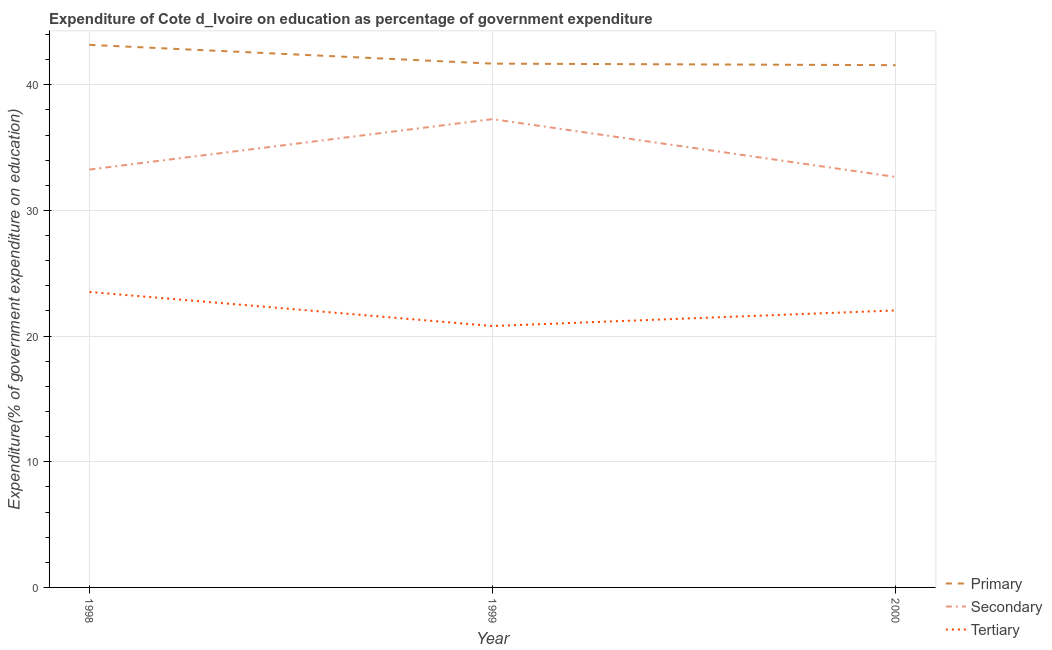How many different coloured lines are there?
Offer a very short reply. 3. What is the expenditure on secondary education in 1999?
Keep it short and to the point. 37.26. Across all years, what is the maximum expenditure on secondary education?
Provide a succinct answer. 37.26. Across all years, what is the minimum expenditure on primary education?
Make the answer very short. 41.56. In which year was the expenditure on tertiary education maximum?
Offer a terse response. 1998. In which year was the expenditure on tertiary education minimum?
Give a very brief answer. 1999. What is the total expenditure on tertiary education in the graph?
Ensure brevity in your answer.  66.36. What is the difference between the expenditure on primary education in 1998 and that in 2000?
Make the answer very short. 1.61. What is the difference between the expenditure on tertiary education in 1999 and the expenditure on secondary education in 1998?
Offer a very short reply. -12.45. What is the average expenditure on tertiary education per year?
Provide a short and direct response. 22.12. In the year 1998, what is the difference between the expenditure on secondary education and expenditure on tertiary education?
Offer a very short reply. 9.74. In how many years, is the expenditure on primary education greater than 38 %?
Your answer should be very brief. 3. What is the ratio of the expenditure on secondary education in 1998 to that in 2000?
Keep it short and to the point. 1.02. Is the expenditure on primary education in 1998 less than that in 2000?
Give a very brief answer. No. Is the difference between the expenditure on secondary education in 1999 and 2000 greater than the difference between the expenditure on primary education in 1999 and 2000?
Keep it short and to the point. Yes. What is the difference between the highest and the second highest expenditure on primary education?
Keep it short and to the point. 1.49. What is the difference between the highest and the lowest expenditure on primary education?
Offer a terse response. 1.61. In how many years, is the expenditure on secondary education greater than the average expenditure on secondary education taken over all years?
Provide a short and direct response. 1. Is the sum of the expenditure on tertiary education in 1998 and 1999 greater than the maximum expenditure on primary education across all years?
Offer a very short reply. Yes. Does the expenditure on primary education monotonically increase over the years?
Your answer should be compact. No. Is the expenditure on primary education strictly greater than the expenditure on secondary education over the years?
Offer a terse response. Yes. How many years are there in the graph?
Make the answer very short. 3. Are the values on the major ticks of Y-axis written in scientific E-notation?
Give a very brief answer. No. Does the graph contain any zero values?
Offer a terse response. No. Does the graph contain grids?
Your response must be concise. Yes. Where does the legend appear in the graph?
Make the answer very short. Bottom right. How many legend labels are there?
Ensure brevity in your answer.  3. What is the title of the graph?
Your answer should be very brief. Expenditure of Cote d_Ivoire on education as percentage of government expenditure. Does "Financial account" appear as one of the legend labels in the graph?
Keep it short and to the point. No. What is the label or title of the Y-axis?
Give a very brief answer. Expenditure(% of government expenditure on education). What is the Expenditure(% of government expenditure on education) of Primary in 1998?
Your response must be concise. 43.17. What is the Expenditure(% of government expenditure on education) in Secondary in 1998?
Provide a succinct answer. 33.25. What is the Expenditure(% of government expenditure on education) of Tertiary in 1998?
Provide a succinct answer. 23.51. What is the Expenditure(% of government expenditure on education) of Primary in 1999?
Give a very brief answer. 41.68. What is the Expenditure(% of government expenditure on education) in Secondary in 1999?
Ensure brevity in your answer.  37.26. What is the Expenditure(% of government expenditure on education) in Tertiary in 1999?
Your answer should be very brief. 20.8. What is the Expenditure(% of government expenditure on education) of Primary in 2000?
Offer a very short reply. 41.56. What is the Expenditure(% of government expenditure on education) of Secondary in 2000?
Provide a short and direct response. 32.67. What is the Expenditure(% of government expenditure on education) in Tertiary in 2000?
Your answer should be compact. 22.04. Across all years, what is the maximum Expenditure(% of government expenditure on education) of Primary?
Give a very brief answer. 43.17. Across all years, what is the maximum Expenditure(% of government expenditure on education) of Secondary?
Provide a succinct answer. 37.26. Across all years, what is the maximum Expenditure(% of government expenditure on education) in Tertiary?
Give a very brief answer. 23.51. Across all years, what is the minimum Expenditure(% of government expenditure on education) of Primary?
Make the answer very short. 41.56. Across all years, what is the minimum Expenditure(% of government expenditure on education) in Secondary?
Provide a succinct answer. 32.67. Across all years, what is the minimum Expenditure(% of government expenditure on education) in Tertiary?
Your answer should be compact. 20.8. What is the total Expenditure(% of government expenditure on education) of Primary in the graph?
Make the answer very short. 126.41. What is the total Expenditure(% of government expenditure on education) in Secondary in the graph?
Your response must be concise. 103.18. What is the total Expenditure(% of government expenditure on education) of Tertiary in the graph?
Your response must be concise. 66.36. What is the difference between the Expenditure(% of government expenditure on education) of Primary in 1998 and that in 1999?
Make the answer very short. 1.49. What is the difference between the Expenditure(% of government expenditure on education) of Secondary in 1998 and that in 1999?
Keep it short and to the point. -4.01. What is the difference between the Expenditure(% of government expenditure on education) in Tertiary in 1998 and that in 1999?
Your response must be concise. 2.71. What is the difference between the Expenditure(% of government expenditure on education) in Primary in 1998 and that in 2000?
Your response must be concise. 1.61. What is the difference between the Expenditure(% of government expenditure on education) of Secondary in 1998 and that in 2000?
Ensure brevity in your answer.  0.59. What is the difference between the Expenditure(% of government expenditure on education) of Tertiary in 1998 and that in 2000?
Provide a short and direct response. 1.47. What is the difference between the Expenditure(% of government expenditure on education) of Primary in 1999 and that in 2000?
Keep it short and to the point. 0.12. What is the difference between the Expenditure(% of government expenditure on education) in Secondary in 1999 and that in 2000?
Keep it short and to the point. 4.6. What is the difference between the Expenditure(% of government expenditure on education) in Tertiary in 1999 and that in 2000?
Offer a terse response. -1.24. What is the difference between the Expenditure(% of government expenditure on education) of Primary in 1998 and the Expenditure(% of government expenditure on education) of Secondary in 1999?
Ensure brevity in your answer.  5.91. What is the difference between the Expenditure(% of government expenditure on education) in Primary in 1998 and the Expenditure(% of government expenditure on education) in Tertiary in 1999?
Your response must be concise. 22.37. What is the difference between the Expenditure(% of government expenditure on education) in Secondary in 1998 and the Expenditure(% of government expenditure on education) in Tertiary in 1999?
Give a very brief answer. 12.45. What is the difference between the Expenditure(% of government expenditure on education) of Primary in 1998 and the Expenditure(% of government expenditure on education) of Secondary in 2000?
Your response must be concise. 10.51. What is the difference between the Expenditure(% of government expenditure on education) in Primary in 1998 and the Expenditure(% of government expenditure on education) in Tertiary in 2000?
Your answer should be compact. 21.13. What is the difference between the Expenditure(% of government expenditure on education) in Secondary in 1998 and the Expenditure(% of government expenditure on education) in Tertiary in 2000?
Make the answer very short. 11.21. What is the difference between the Expenditure(% of government expenditure on education) in Primary in 1999 and the Expenditure(% of government expenditure on education) in Secondary in 2000?
Offer a very short reply. 9.02. What is the difference between the Expenditure(% of government expenditure on education) in Primary in 1999 and the Expenditure(% of government expenditure on education) in Tertiary in 2000?
Ensure brevity in your answer.  19.64. What is the difference between the Expenditure(% of government expenditure on education) of Secondary in 1999 and the Expenditure(% of government expenditure on education) of Tertiary in 2000?
Offer a very short reply. 15.22. What is the average Expenditure(% of government expenditure on education) of Primary per year?
Ensure brevity in your answer.  42.14. What is the average Expenditure(% of government expenditure on education) in Secondary per year?
Make the answer very short. 34.39. What is the average Expenditure(% of government expenditure on education) of Tertiary per year?
Make the answer very short. 22.12. In the year 1998, what is the difference between the Expenditure(% of government expenditure on education) in Primary and Expenditure(% of government expenditure on education) in Secondary?
Your response must be concise. 9.92. In the year 1998, what is the difference between the Expenditure(% of government expenditure on education) in Primary and Expenditure(% of government expenditure on education) in Tertiary?
Your answer should be very brief. 19.66. In the year 1998, what is the difference between the Expenditure(% of government expenditure on education) in Secondary and Expenditure(% of government expenditure on education) in Tertiary?
Keep it short and to the point. 9.74. In the year 1999, what is the difference between the Expenditure(% of government expenditure on education) in Primary and Expenditure(% of government expenditure on education) in Secondary?
Your answer should be very brief. 4.42. In the year 1999, what is the difference between the Expenditure(% of government expenditure on education) in Primary and Expenditure(% of government expenditure on education) in Tertiary?
Your answer should be very brief. 20.88. In the year 1999, what is the difference between the Expenditure(% of government expenditure on education) of Secondary and Expenditure(% of government expenditure on education) of Tertiary?
Give a very brief answer. 16.46. In the year 2000, what is the difference between the Expenditure(% of government expenditure on education) in Primary and Expenditure(% of government expenditure on education) in Secondary?
Provide a short and direct response. 8.89. In the year 2000, what is the difference between the Expenditure(% of government expenditure on education) in Primary and Expenditure(% of government expenditure on education) in Tertiary?
Keep it short and to the point. 19.52. In the year 2000, what is the difference between the Expenditure(% of government expenditure on education) of Secondary and Expenditure(% of government expenditure on education) of Tertiary?
Provide a short and direct response. 10.62. What is the ratio of the Expenditure(% of government expenditure on education) of Primary in 1998 to that in 1999?
Your answer should be very brief. 1.04. What is the ratio of the Expenditure(% of government expenditure on education) in Secondary in 1998 to that in 1999?
Provide a succinct answer. 0.89. What is the ratio of the Expenditure(% of government expenditure on education) of Tertiary in 1998 to that in 1999?
Offer a terse response. 1.13. What is the ratio of the Expenditure(% of government expenditure on education) in Primary in 1998 to that in 2000?
Your answer should be compact. 1.04. What is the ratio of the Expenditure(% of government expenditure on education) of Secondary in 1998 to that in 2000?
Ensure brevity in your answer.  1.02. What is the ratio of the Expenditure(% of government expenditure on education) in Tertiary in 1998 to that in 2000?
Your answer should be compact. 1.07. What is the ratio of the Expenditure(% of government expenditure on education) of Secondary in 1999 to that in 2000?
Give a very brief answer. 1.14. What is the ratio of the Expenditure(% of government expenditure on education) in Tertiary in 1999 to that in 2000?
Provide a succinct answer. 0.94. What is the difference between the highest and the second highest Expenditure(% of government expenditure on education) in Primary?
Offer a terse response. 1.49. What is the difference between the highest and the second highest Expenditure(% of government expenditure on education) of Secondary?
Keep it short and to the point. 4.01. What is the difference between the highest and the second highest Expenditure(% of government expenditure on education) of Tertiary?
Keep it short and to the point. 1.47. What is the difference between the highest and the lowest Expenditure(% of government expenditure on education) of Primary?
Offer a terse response. 1.61. What is the difference between the highest and the lowest Expenditure(% of government expenditure on education) in Secondary?
Offer a very short reply. 4.6. What is the difference between the highest and the lowest Expenditure(% of government expenditure on education) in Tertiary?
Keep it short and to the point. 2.71. 